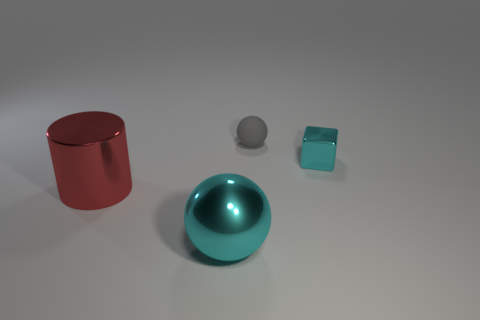There is a big object that is to the right of the large object that is on the left side of the cyan shiny thing to the left of the gray rubber thing; what is it made of?
Offer a terse response. Metal. The matte thing that is the same size as the metal block is what shape?
Offer a very short reply. Sphere. Is there a tiny sphere that has the same color as the large ball?
Provide a succinct answer. No. The cyan cube is what size?
Provide a succinct answer. Small. Do the tiny block and the large sphere have the same material?
Your answer should be very brief. Yes. How many big cyan metal things are right of the sphere on the right side of the cyan metal thing left of the small shiny cube?
Provide a short and direct response. 0. What is the shape of the shiny thing that is in front of the large metal cylinder?
Your answer should be very brief. Sphere. What number of other objects are the same material as the large cyan object?
Provide a succinct answer. 2. Is the color of the rubber ball the same as the small block?
Your answer should be compact. No. Is the number of large balls left of the large cyan metallic ball less than the number of large red metallic things behind the big red thing?
Your answer should be compact. No. 